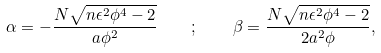Convert formula to latex. <formula><loc_0><loc_0><loc_500><loc_500>\alpha = - \frac { N \sqrt { n \epsilon ^ { 2 } \phi ^ { 4 } - 2 } } { a \phi ^ { 2 } } \quad ; \quad \beta = \frac { N \sqrt { n \epsilon ^ { 2 } \phi ^ { 4 } - 2 } } { 2 a ^ { 2 } \phi } ,</formula> 